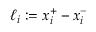<formula> <loc_0><loc_0><loc_500><loc_500>\ell _ { i } \colon = x _ { i } ^ { + } - x _ { i } ^ { - }</formula> 